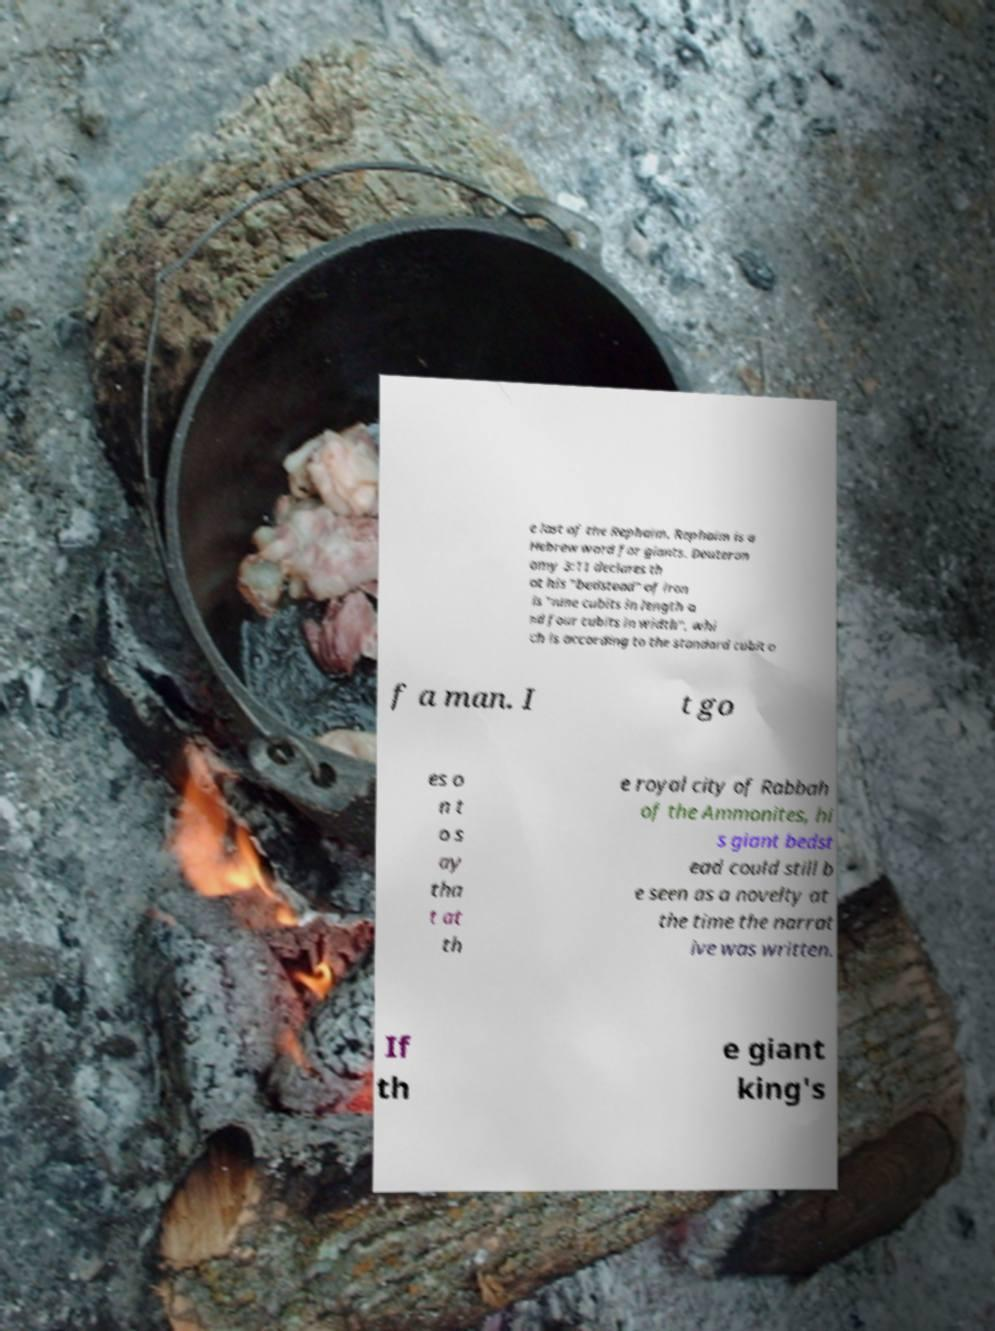Please identify and transcribe the text found in this image. e last of the Rephaim. Rephaim is a Hebrew word for giants. Deuteron omy 3:11 declares th at his "bedstead" of iron is "nine cubits in length a nd four cubits in width", whi ch is according to the standard cubit o f a man. I t go es o n t o s ay tha t at th e royal city of Rabbah of the Ammonites, hi s giant bedst ead could still b e seen as a novelty at the time the narrat ive was written. If th e giant king's 